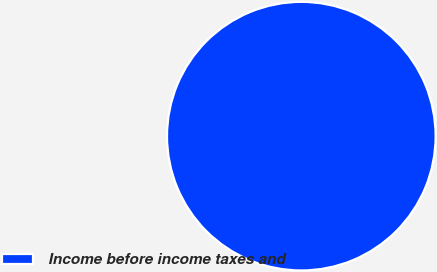Convert chart. <chart><loc_0><loc_0><loc_500><loc_500><pie_chart><fcel>Income before income taxes and<nl><fcel>100.0%<nl></chart> 